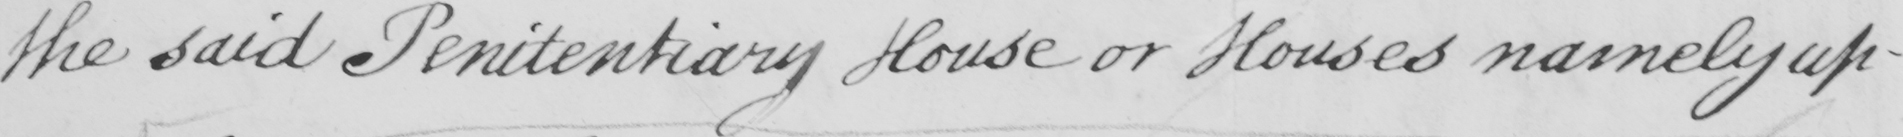What does this handwritten line say? the said Penitentiary House or Houses namely up- 